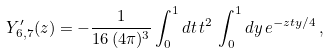Convert formula to latex. <formula><loc_0><loc_0><loc_500><loc_500>Y _ { 6 , 7 } ^ { \prime } ( z ) = - \frac { 1 } { 1 6 \, ( 4 \pi ) ^ { 3 } } \int _ { 0 } ^ { 1 } d t \, t ^ { 2 } \, \int _ { 0 } ^ { 1 } d y \, e ^ { - z t y / 4 } \, ,</formula> 